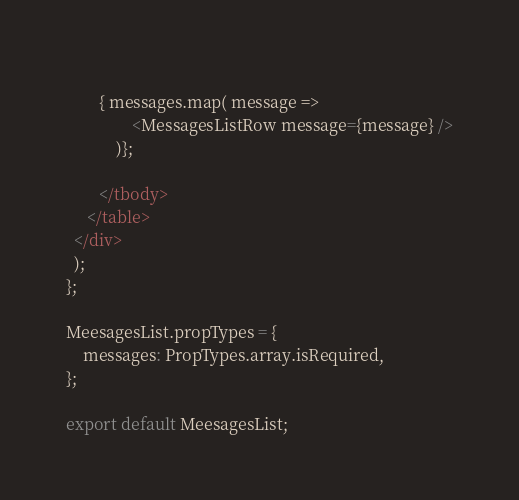<code> <loc_0><loc_0><loc_500><loc_500><_JavaScript_>            
        { messages.map( message =>             
                <MessagesListRow message={message} />
            )};     
        
        </tbody>
     </table>
  </div>
  );
};

MeesagesList.propTypes = {
    messages: PropTypes.array.isRequired,
};

export default MeesagesList;
</code> 